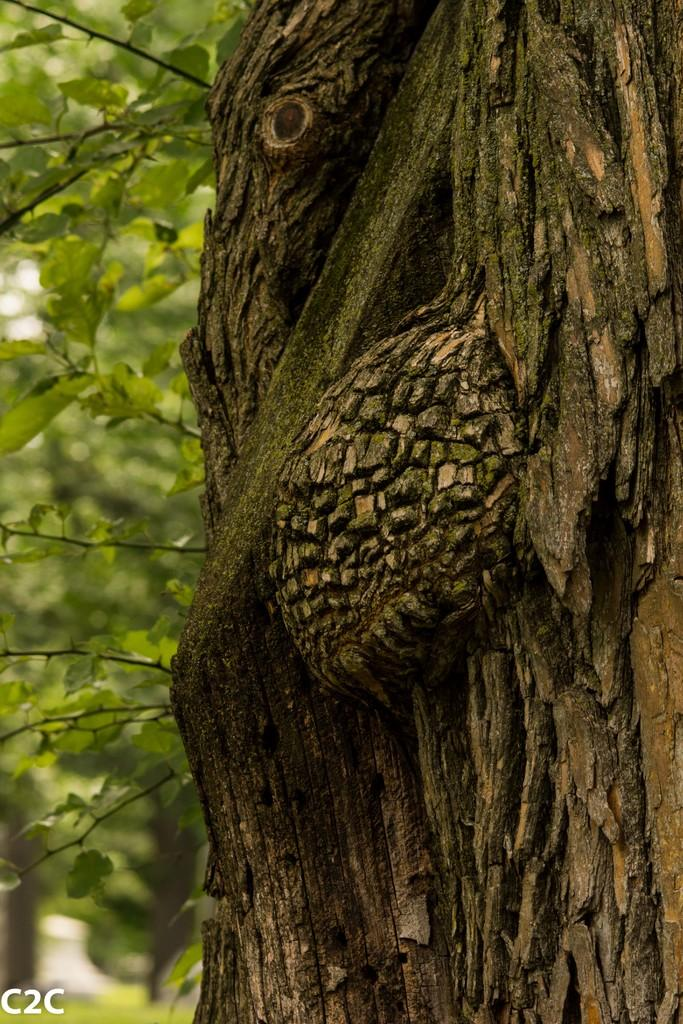What can be seen on the right side of the image? There is a bark of a tree on the right side of the image. What is present on the left side of the image? There are some leaves on the left side of the image. How many cacti can be seen in the image? There are no cacti present in the image. Is there a ladybug crawling on the bark of the tree in the image? There is no ladybug visible in the image. 